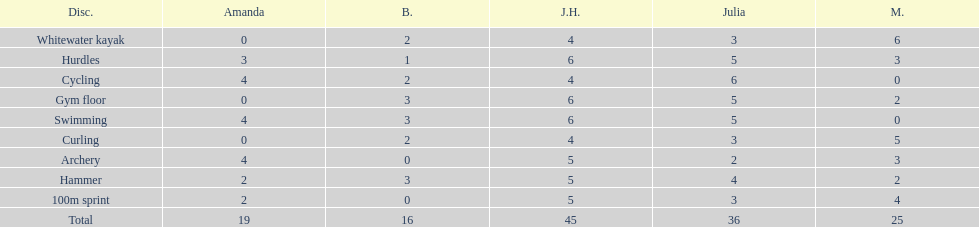Which of the girls had the least amount in archery? Bernie. 